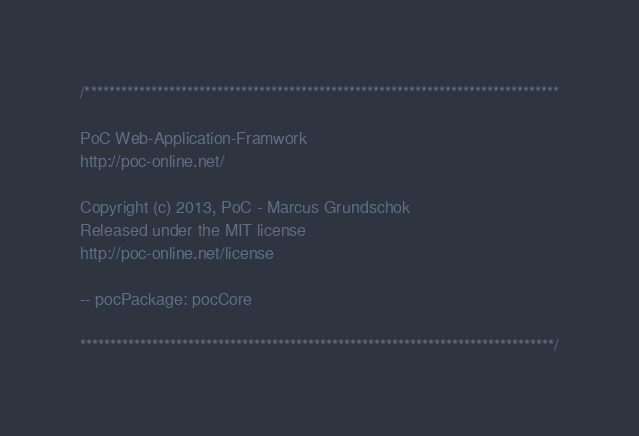Convert code to text. <code><loc_0><loc_0><loc_500><loc_500><_SQL_>/*******************************************************************************

PoC Web-Application-Framwork
http://poc-online.net/

Copyright (c) 2013, PoC - Marcus Grundschok
Released under the MIT license
http://poc-online.net/license

-- pocPackage: pocCore

*******************************************************************************/
</code> 